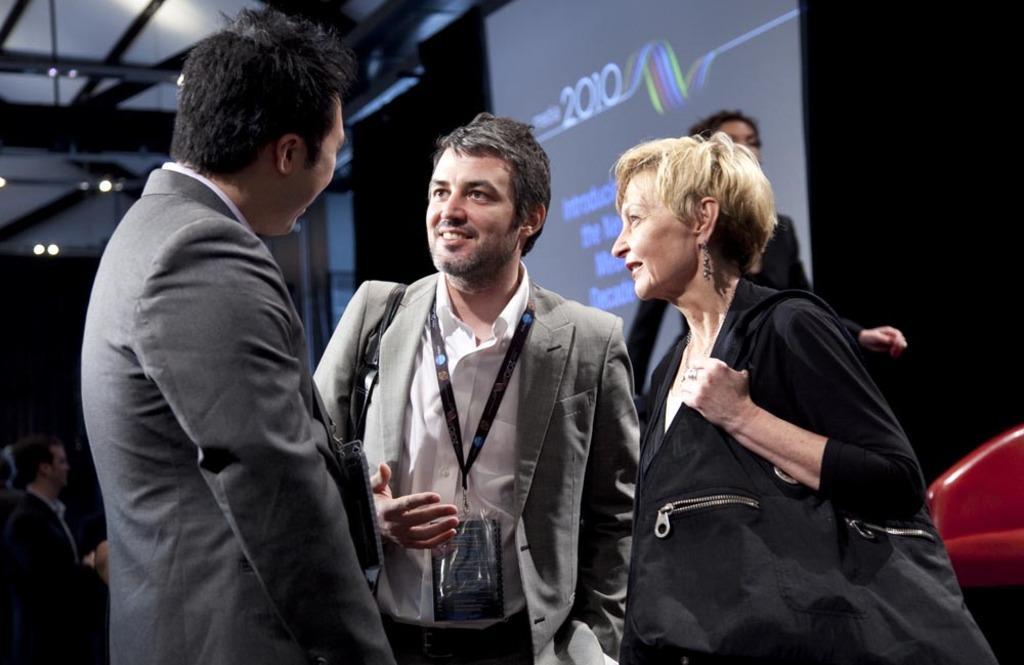Describe this image in one or two sentences. In the center of the image we can see two men and a woman standing. In the background we can see the screen and we can see the text present on the screen. We can also see few people in the background and at the top we can see the roof for shelter. We can also see the lights. 